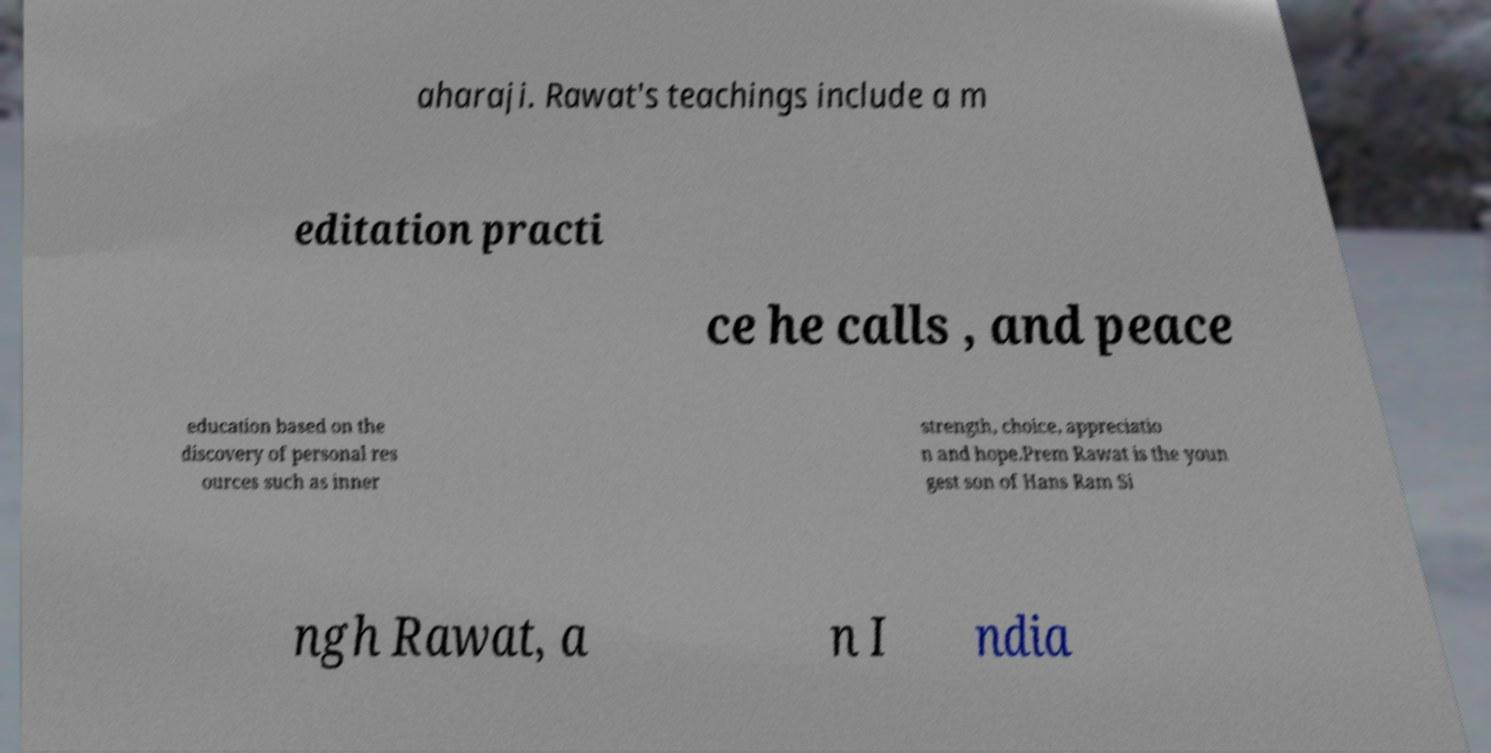Please read and relay the text visible in this image. What does it say? aharaji. Rawat's teachings include a m editation practi ce he calls , and peace education based on the discovery of personal res ources such as inner strength, choice, appreciatio n and hope.Prem Rawat is the youn gest son of Hans Ram Si ngh Rawat, a n I ndia 